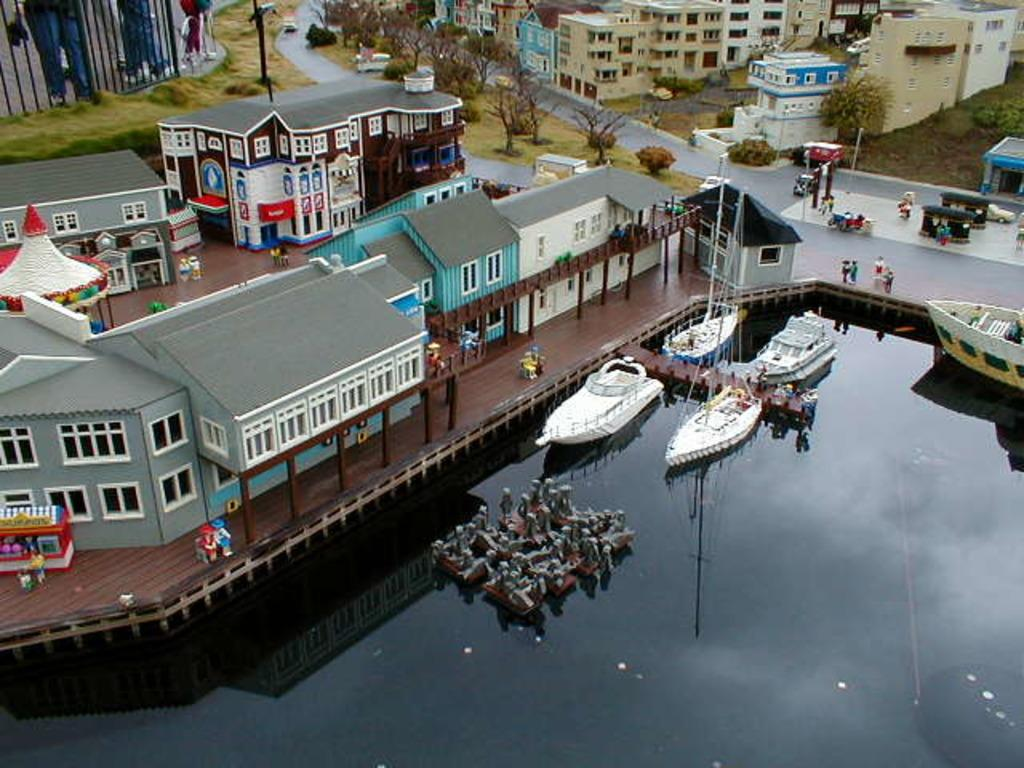What type of view is depicted in the image? The image is an aerial view. What structures can be seen in the image? There are buildings in the image. What type of vegetation is present in the image? There are trees in the image. What are the poles used for in the image? The purpose of the poles in the image is not specified, but they could be used for various purposes such as streetlights or utility poles. What is happening on the road in the image? There are vehicles and people on the road in the image. What is present on the water in the image? There are boats on the water in the image. What type of glove is being used by the hand in the image? There is no glove or hand present in the image. 